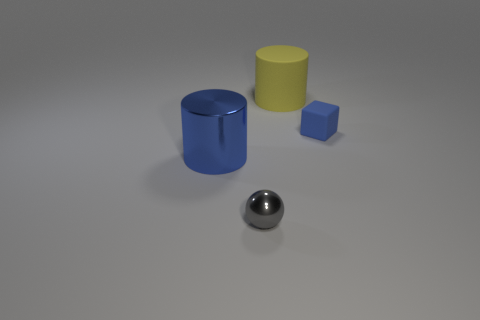Add 1 blue metal objects. How many objects exist? 5 Subtract all cubes. How many objects are left? 3 Add 3 large things. How many large things are left? 5 Add 4 big purple shiny blocks. How many big purple shiny blocks exist? 4 Subtract 0 red spheres. How many objects are left? 4 Subtract all big blue objects. Subtract all big green matte cylinders. How many objects are left? 3 